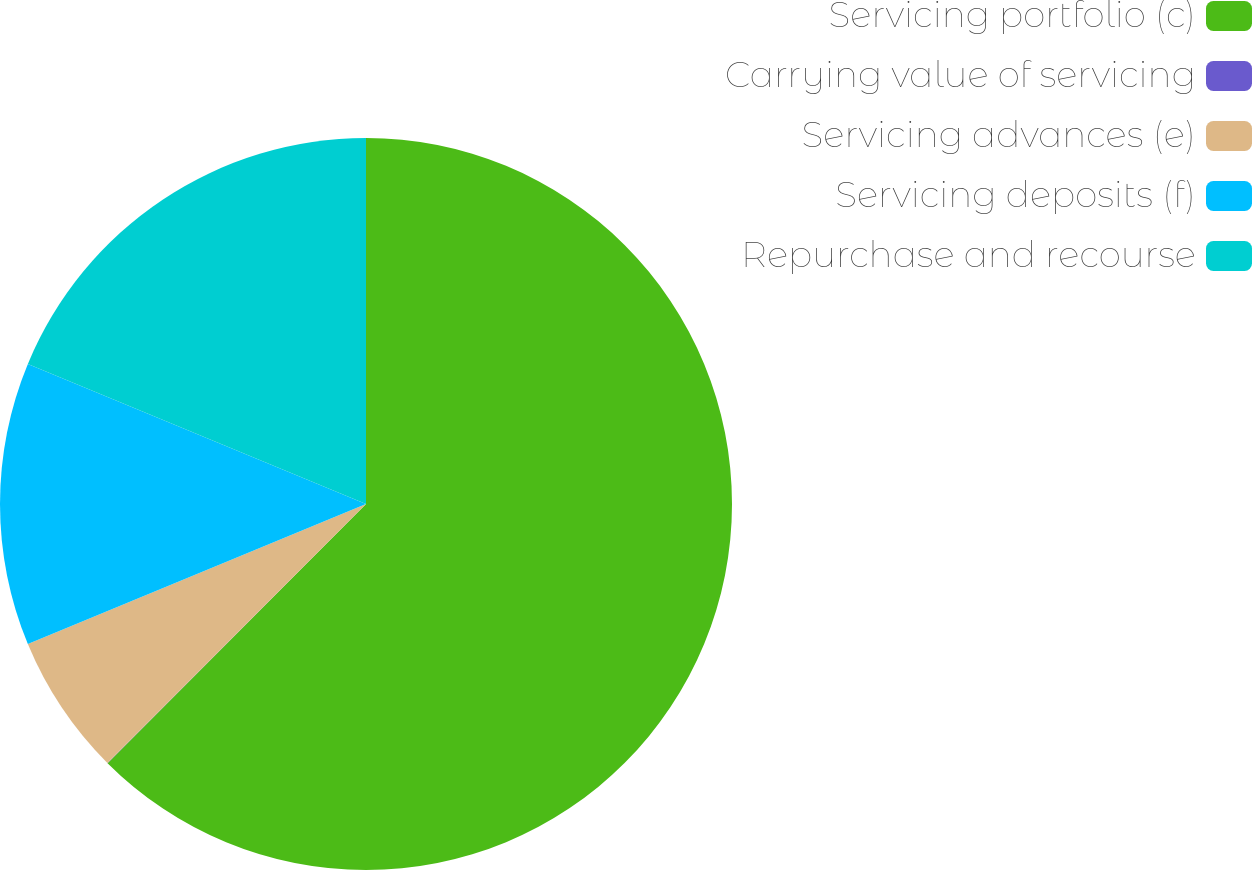<chart> <loc_0><loc_0><loc_500><loc_500><pie_chart><fcel>Servicing portfolio (c)<fcel>Carrying value of servicing<fcel>Servicing advances (e)<fcel>Servicing deposits (f)<fcel>Repurchase and recourse<nl><fcel>62.48%<fcel>0.01%<fcel>6.26%<fcel>12.5%<fcel>18.75%<nl></chart> 